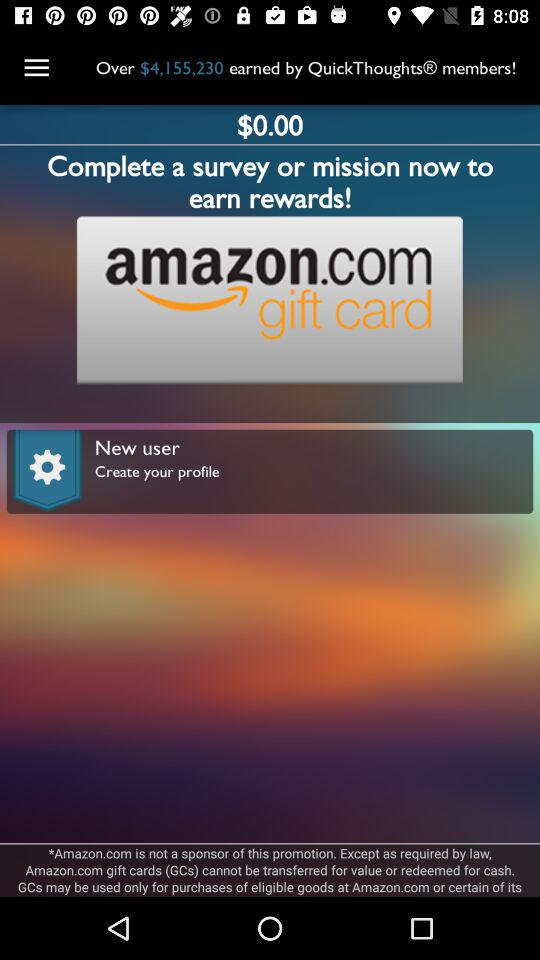What is the total amount of money earned by "QuickThoughts" members? The total amount of earned money is over $4,155,230. 